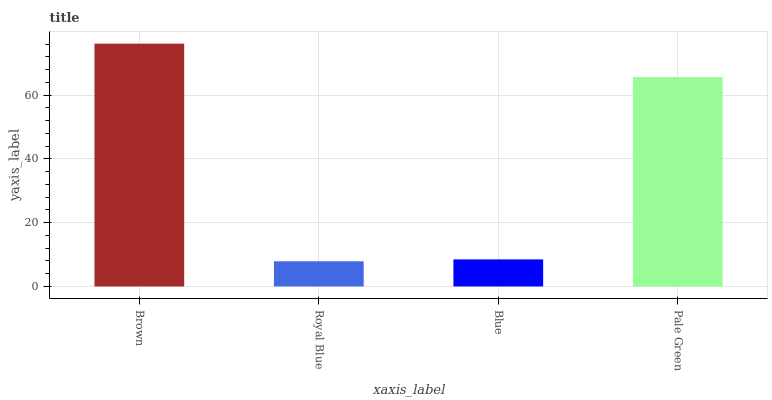Is Royal Blue the minimum?
Answer yes or no. Yes. Is Brown the maximum?
Answer yes or no. Yes. Is Blue the minimum?
Answer yes or no. No. Is Blue the maximum?
Answer yes or no. No. Is Blue greater than Royal Blue?
Answer yes or no. Yes. Is Royal Blue less than Blue?
Answer yes or no. Yes. Is Royal Blue greater than Blue?
Answer yes or no. No. Is Blue less than Royal Blue?
Answer yes or no. No. Is Pale Green the high median?
Answer yes or no. Yes. Is Blue the low median?
Answer yes or no. Yes. Is Royal Blue the high median?
Answer yes or no. No. Is Brown the low median?
Answer yes or no. No. 